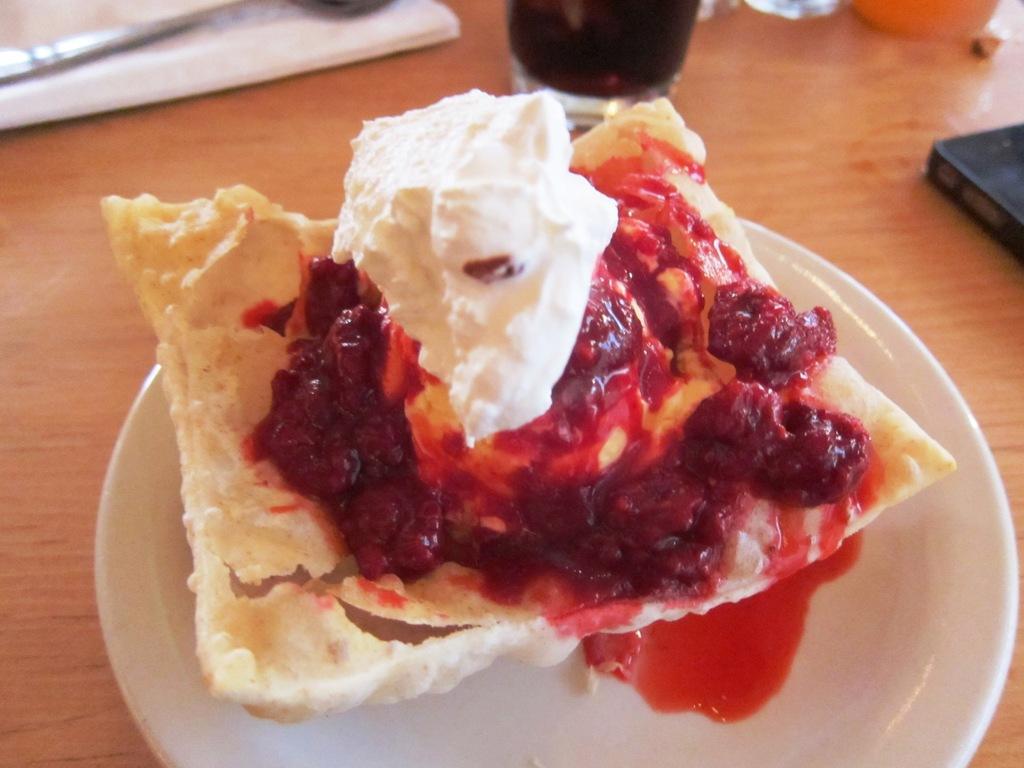Could you give a brief overview of what you see in this image? In this picture we can see a table, there are two plates, a glass of drink present on the table, we can see some food and sauce present in this plate. 